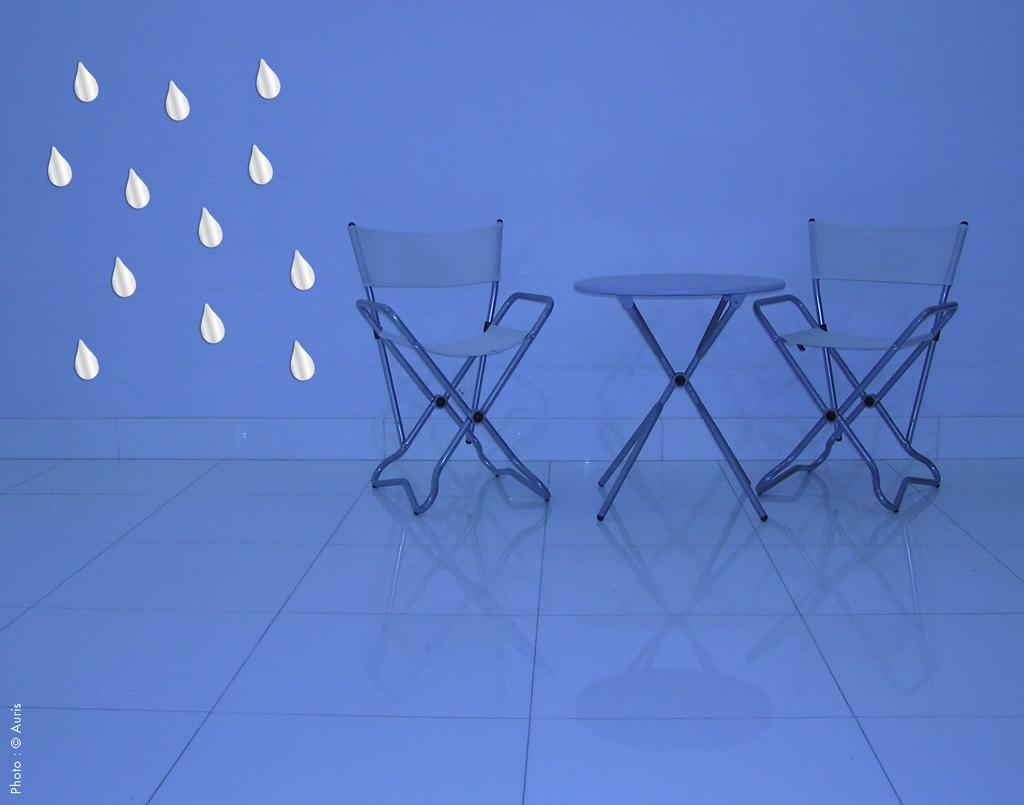How many chairs are visible in the image? There are two chairs in the image. What other piece of furniture is present in the image? There is a table in the image. Where are the chairs and table located? The chairs and table are on the floor. What type of education is being discussed in the image? There is no discussion or education present in the image; it only features chairs, a table, and their location on the floor. 